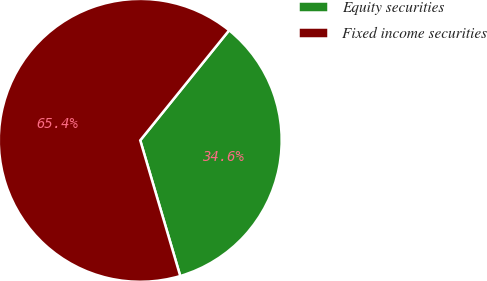Convert chart to OTSL. <chart><loc_0><loc_0><loc_500><loc_500><pie_chart><fcel>Equity securities<fcel>Fixed income securities<nl><fcel>34.62%<fcel>65.38%<nl></chart> 